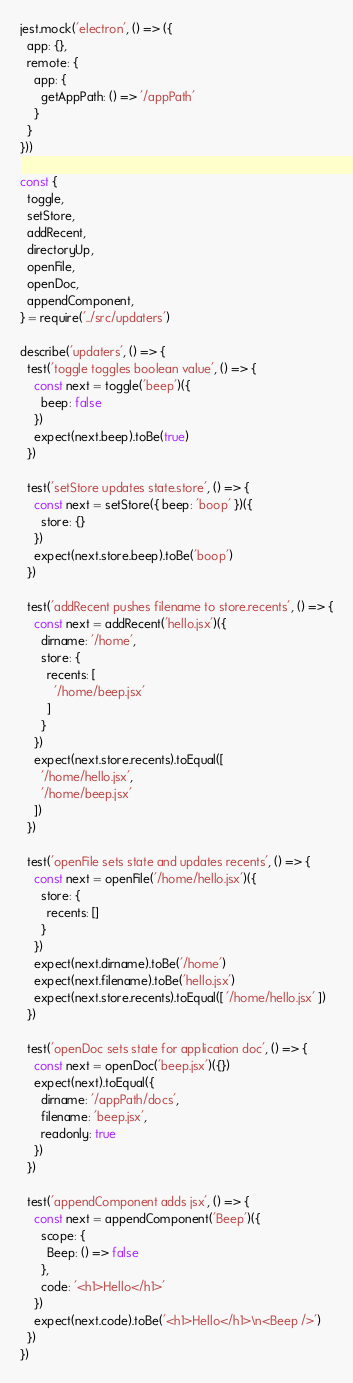Convert code to text. <code><loc_0><loc_0><loc_500><loc_500><_JavaScript_>jest.mock('electron', () => ({
  app: {},
  remote: {
    app: {
      getAppPath: () => '/appPath'
    }
  }
}))

const {
  toggle,
  setStore,
  addRecent,
  directoryUp,
  openFile,
  openDoc,
  appendComponent,
} = require('../src/updaters')

describe('updaters', () => {
  test('toggle toggles boolean value', () => {
    const next = toggle('beep')({
      beep: false
    })
    expect(next.beep).toBe(true)
  })

  test('setStore updates state.store', () => {
    const next = setStore({ beep: 'boop' })({
      store: {}
    })
    expect(next.store.beep).toBe('boop')
  })

  test('addRecent pushes filename to store.recents', () => {
    const next = addRecent('hello.jsx')({
      dirname: '/home',
      store: {
        recents: [
          '/home/beep.jsx'
        ]
      }
    })
    expect(next.store.recents).toEqual([
      '/home/hello.jsx',
      '/home/beep.jsx'
    ])
  })

  test('openFile sets state and updates recents', () => {
    const next = openFile('/home/hello.jsx')({
      store: {
        recents: []
      }
    })
    expect(next.dirname).toBe('/home')
    expect(next.filename).toBe('hello.jsx')
    expect(next.store.recents).toEqual([ '/home/hello.jsx' ])
  })

  test('openDoc sets state for application doc', () => {
    const next = openDoc('beep.jsx')({})
    expect(next).toEqual({
      dirname: '/appPath/docs',
      filename: 'beep.jsx',
      readonly: true
    })
  })

  test('appendComponent adds jsx', () => {
    const next = appendComponent('Beep')({
      scope: {
        Beep: () => false
      },
      code: '<h1>Hello</h1>'
    })
    expect(next.code).toBe('<h1>Hello</h1>\n<Beep />')
  })
})
</code> 